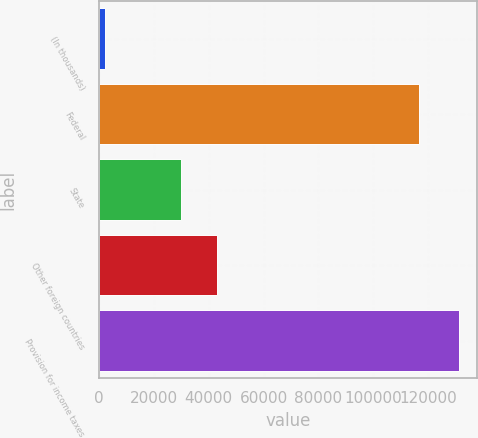Convert chart to OTSL. <chart><loc_0><loc_0><loc_500><loc_500><bar_chart><fcel>(In thousands)<fcel>Federal<fcel>State<fcel>Other foreign countries<fcel>Provision for income taxes<nl><fcel>2016<fcel>116637<fcel>29989<fcel>42917.7<fcel>131303<nl></chart> 